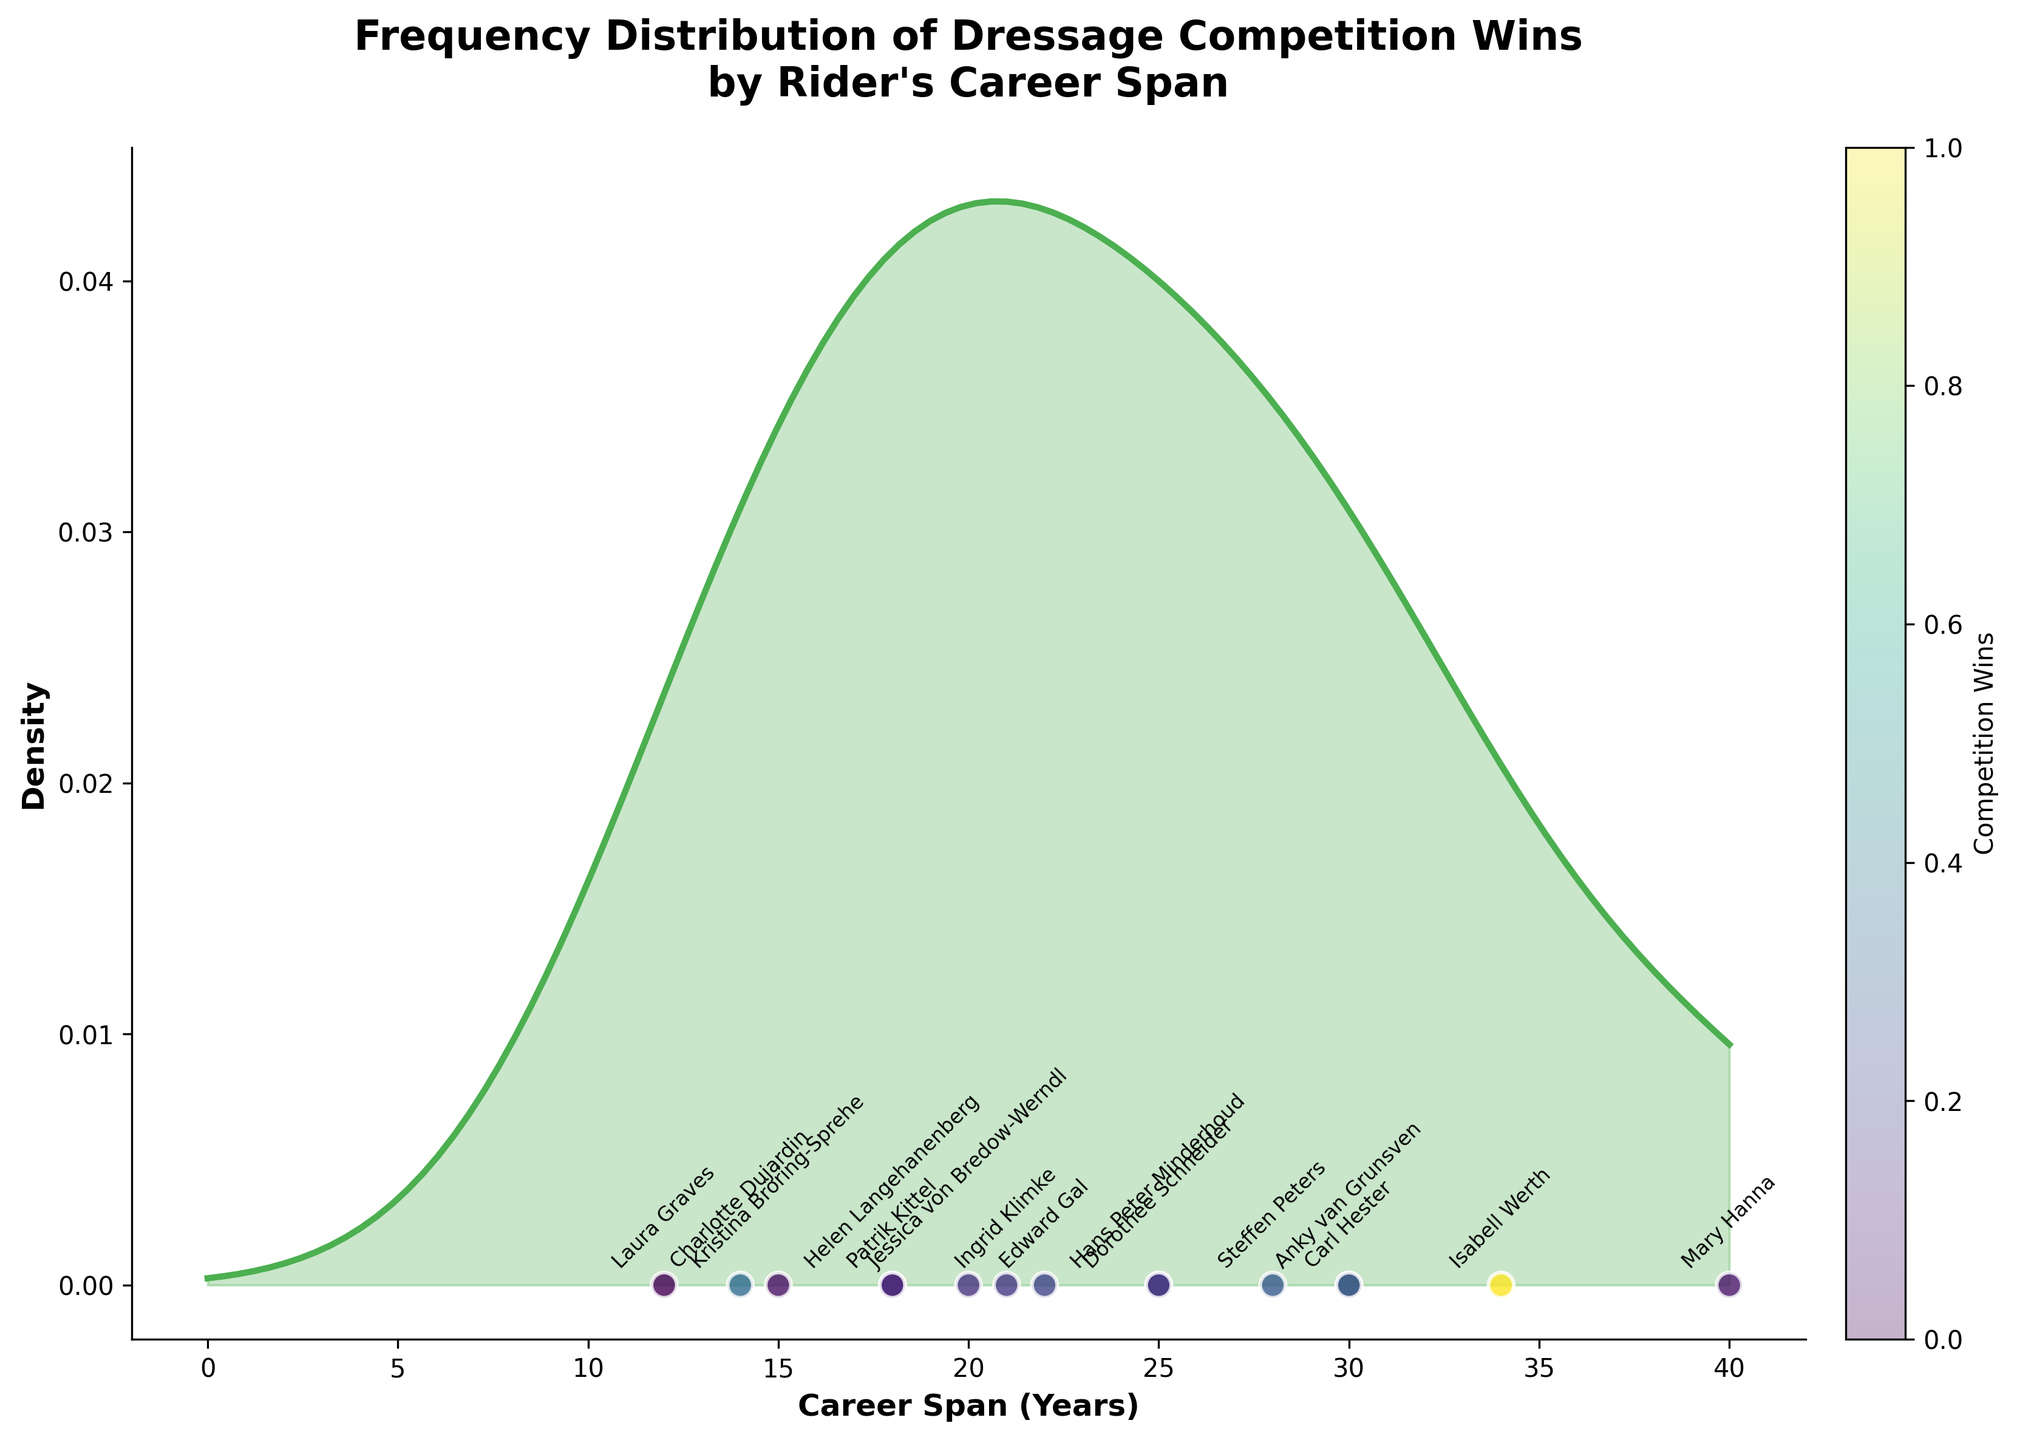What is the main title of the figure? The main title of the figure is located at the top and summarizes the chart. The title is "Frequency Distribution of Dressage Competition Wins by Rider's Career Span."
Answer: Frequency Distribution of Dressage Competition Wins by Rider's Career Span What do the colors of the scatter points represent? The scatter points' colors vary and correspond to a specific metric indicated by the color bar at the side of the plot. They represent the number of competition wins for each rider.
Answer: Competition Wins What does the green shaded area represent? Observing the green shaded area, it appears to follow a smoothed curve. This area represents the density of riders' career spans, showing how frequently certain career span lengths occur among the riders.
Answer: Career Span Density Whose career span is marked with the highest competition wins? By examining the scatter plot, we identify the rider with the point that has the darkest color, which corresponds to the highest value on the color bar. The rider with the highest competition wins is Isabell Werth.
Answer: Isabell Werth How many riders have a career span of more than 30 years? Checking the x-axis for career spans greater than 30, we observe only a couple of scatter points in that range. The riders that fit this criterion are Mary Hanna (40 years) and Isabell Werth (34 years).
Answer: 2 Between Edward Gal and Patrik Kittel, who has a longer career span and how many years is the difference? By locating both riders’ points and comparing their positions along the x-axis, we find that Edward Gal has a career span of 22 years while Patrik Kittel has a span of 18 years. The difference in their career spans is 22 - 18 = 4 years.
Answer: Edward Gal, 4 years Which rider has the shortest career span represented in the plot? Looking at the scatter points along the x-axis and identifying the one closest to zero, we find that Laura Graves has the shortest career span of 12 years.
Answer: Laura Graves Is there a positive correlation between career span and competition wins? Checking the scatter plot, we observe if higher career spans align with higher values on the color bar. While longer career spans tend to have more wins, there are exceptions. Thus, there is a general trend but not a strict positive correlation.
Answer: General trend but not strict How does the density curve behave beyond a 30-year career span? Observing the density curve to the right of the 30-year mark, we see that it declines sharply, indicating that fewer riders have career spans longer than 30 years.
Answer: Declines sharply Which rider has relatively few competition wins compared to their long career span? Identifying the riders with both long career spans and fewer competition wins, we conclude that Mary Hanna, with a career span of 40 years but only 36 competition wins, fits this criterion.
Answer: Mary Hanna 